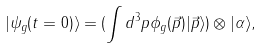Convert formula to latex. <formula><loc_0><loc_0><loc_500><loc_500>| \psi _ { g } ( t = 0 ) \rangle = ( \int d ^ { 3 } p \phi _ { g } ( \vec { p } ) | \vec { p } \rangle ) \otimes | \alpha \rangle ,</formula> 